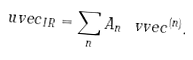Convert formula to latex. <formula><loc_0><loc_0><loc_500><loc_500>\ u v e c _ { I R } = \sum _ { n } A _ { n } \ v v e c ^ { ( n ) } .</formula> 